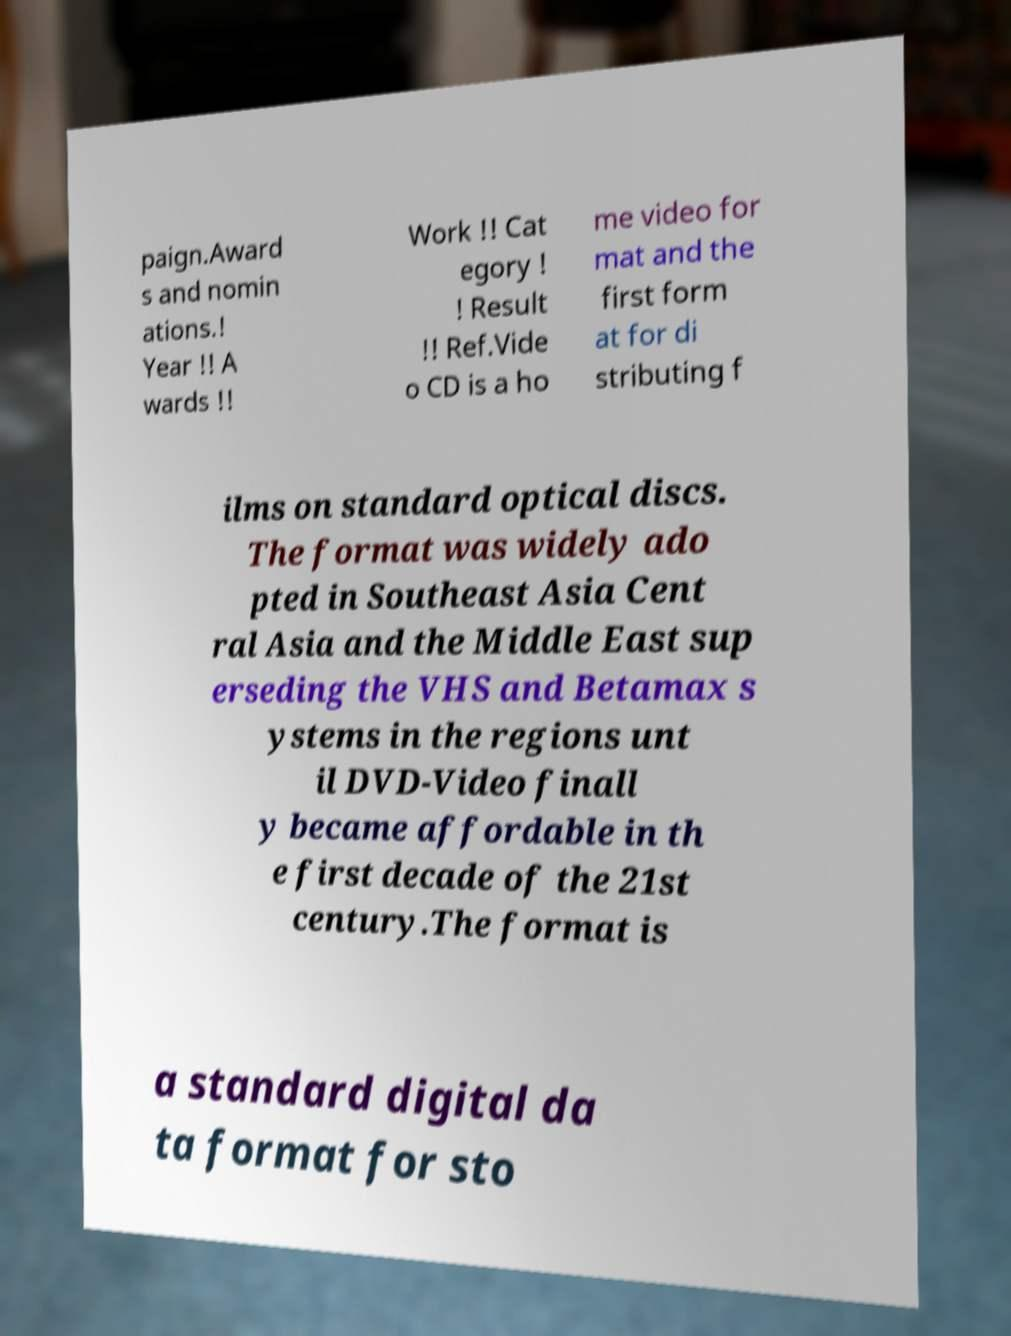Could you assist in decoding the text presented in this image and type it out clearly? paign.Award s and nomin ations.! Year !! A wards !! Work !! Cat egory ! ! Result !! Ref.Vide o CD is a ho me video for mat and the first form at for di stributing f ilms on standard optical discs. The format was widely ado pted in Southeast Asia Cent ral Asia and the Middle East sup erseding the VHS and Betamax s ystems in the regions unt il DVD-Video finall y became affordable in th e first decade of the 21st century.The format is a standard digital da ta format for sto 